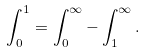<formula> <loc_0><loc_0><loc_500><loc_500>\int _ { 0 } ^ { 1 } = \int _ { 0 } ^ { \infty } - \int _ { 1 } ^ { \infty } .</formula> 